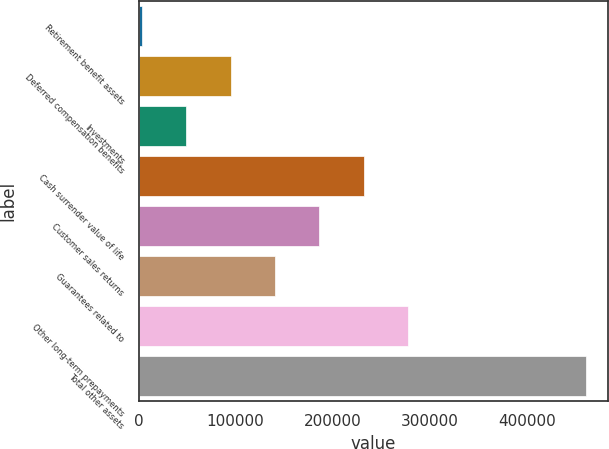Convert chart. <chart><loc_0><loc_0><loc_500><loc_500><bar_chart><fcel>Retirement benefit assets<fcel>Deferred compensation benefits<fcel>Investments<fcel>Cash surrender value of life<fcel>Customer sales returns<fcel>Guarantees related to<fcel>Other long-term prepayments<fcel>Total other assets<nl><fcel>3336<fcel>94852.4<fcel>49094.2<fcel>232127<fcel>186369<fcel>140611<fcel>277885<fcel>460918<nl></chart> 